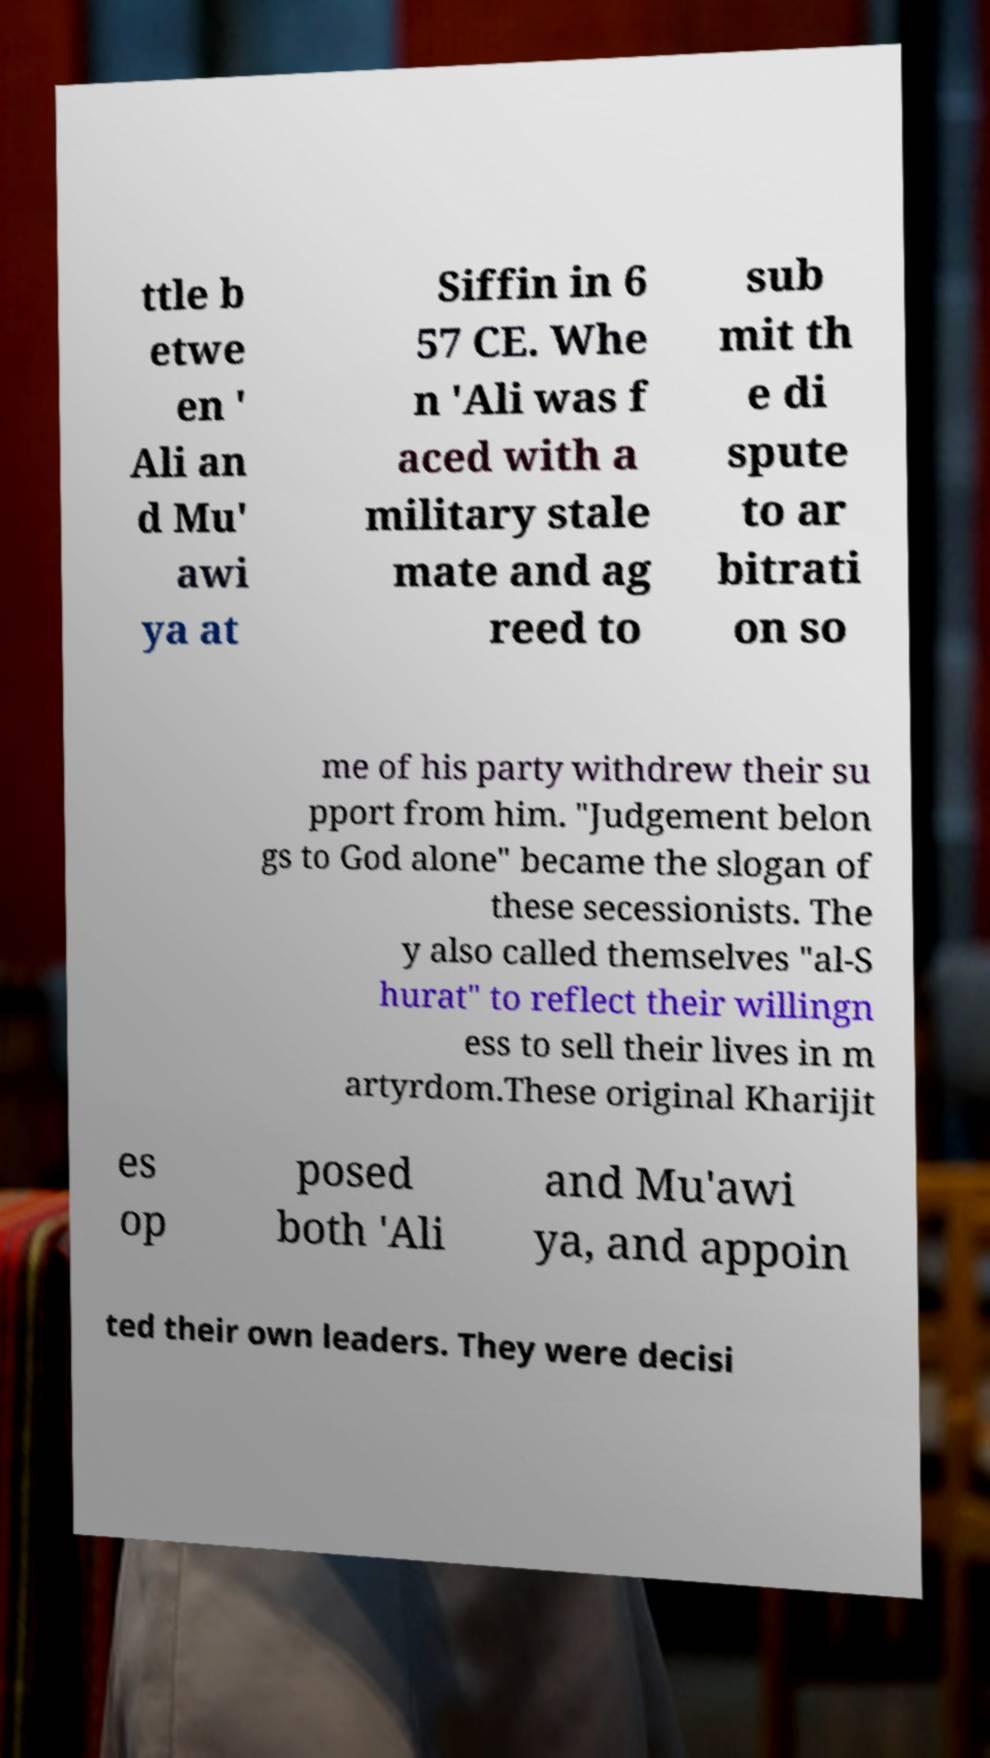Please identify and transcribe the text found in this image. ttle b etwe en ' Ali an d Mu' awi ya at Siffin in 6 57 CE. Whe n 'Ali was f aced with a military stale mate and ag reed to sub mit th e di spute to ar bitrati on so me of his party withdrew their su pport from him. "Judgement belon gs to God alone" became the slogan of these secessionists. The y also called themselves "al-S hurat" to reflect their willingn ess to sell their lives in m artyrdom.These original Kharijit es op posed both 'Ali and Mu'awi ya, and appoin ted their own leaders. They were decisi 